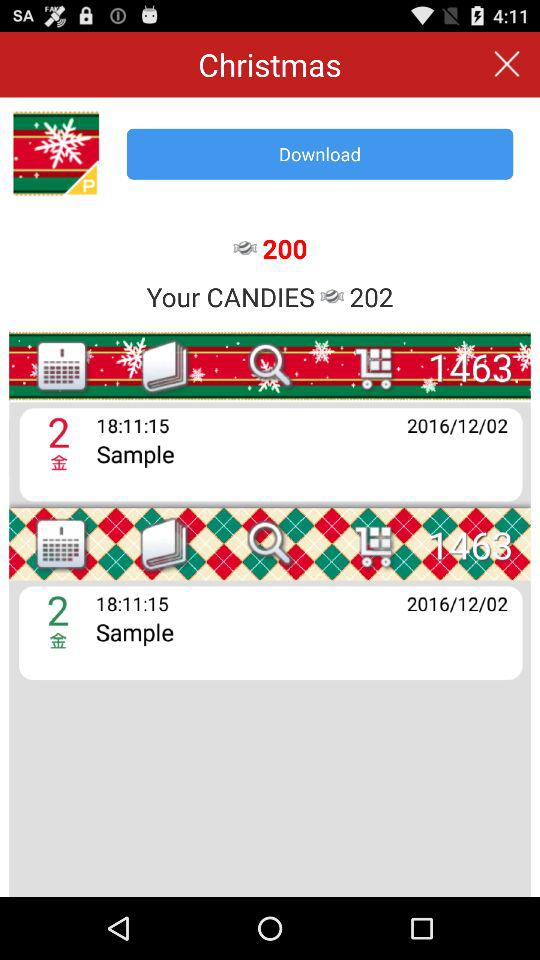How many candies does the user have? The user has 202 candies. 